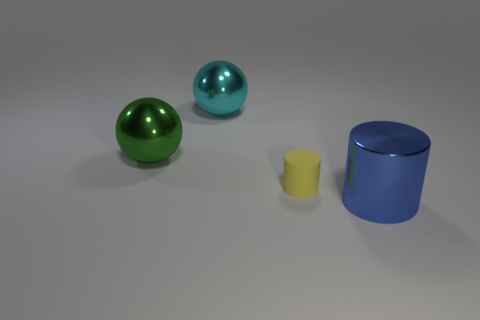What might be the function of the objects if they were real-world items? If the objects were real-world items, the spheres might represent decorative ornaments or perhaps scaled models of globes, having a glossy finish for aesthetic appeal. The cylinders could serve a variety of purposes such as storage containers or stands, depending on their actual size and material. 